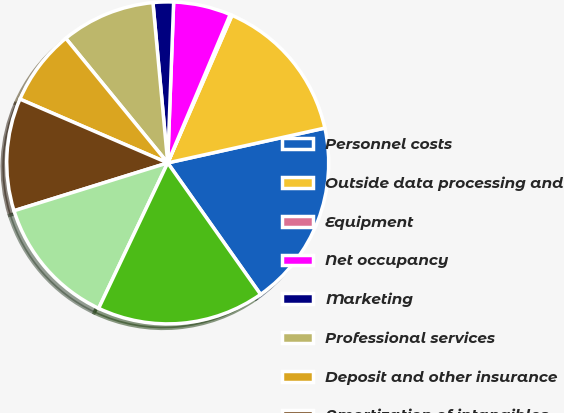Convert chart. <chart><loc_0><loc_0><loc_500><loc_500><pie_chart><fcel>Personnel costs<fcel>Outside data processing and<fcel>Equipment<fcel>Net occupancy<fcel>Marketing<fcel>Professional services<fcel>Deposit and other insurance<fcel>Amortization of intangibles<fcel>Other expense<fcel>Total noninterest expense<nl><fcel>18.69%<fcel>14.99%<fcel>0.2%<fcel>5.75%<fcel>2.05%<fcel>9.45%<fcel>7.6%<fcel>11.29%<fcel>13.14%<fcel>16.84%<nl></chart> 